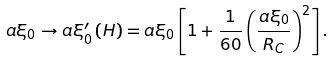<formula> <loc_0><loc_0><loc_500><loc_500>a \xi _ { 0 } \to a \xi _ { 0 } ^ { \prime } \left ( H \right ) = a \xi _ { 0 } \left [ 1 + \frac { 1 } { 6 0 } \left ( \frac { a \xi _ { 0 } } { R _ { C } } \right ) ^ { 2 } \right ] .</formula> 